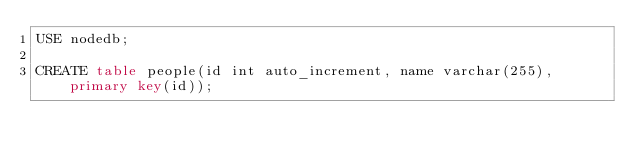Convert code to text. <code><loc_0><loc_0><loc_500><loc_500><_SQL_>USE nodedb;

CREATE table people(id int auto_increment, name varchar(255), primary key(id));</code> 